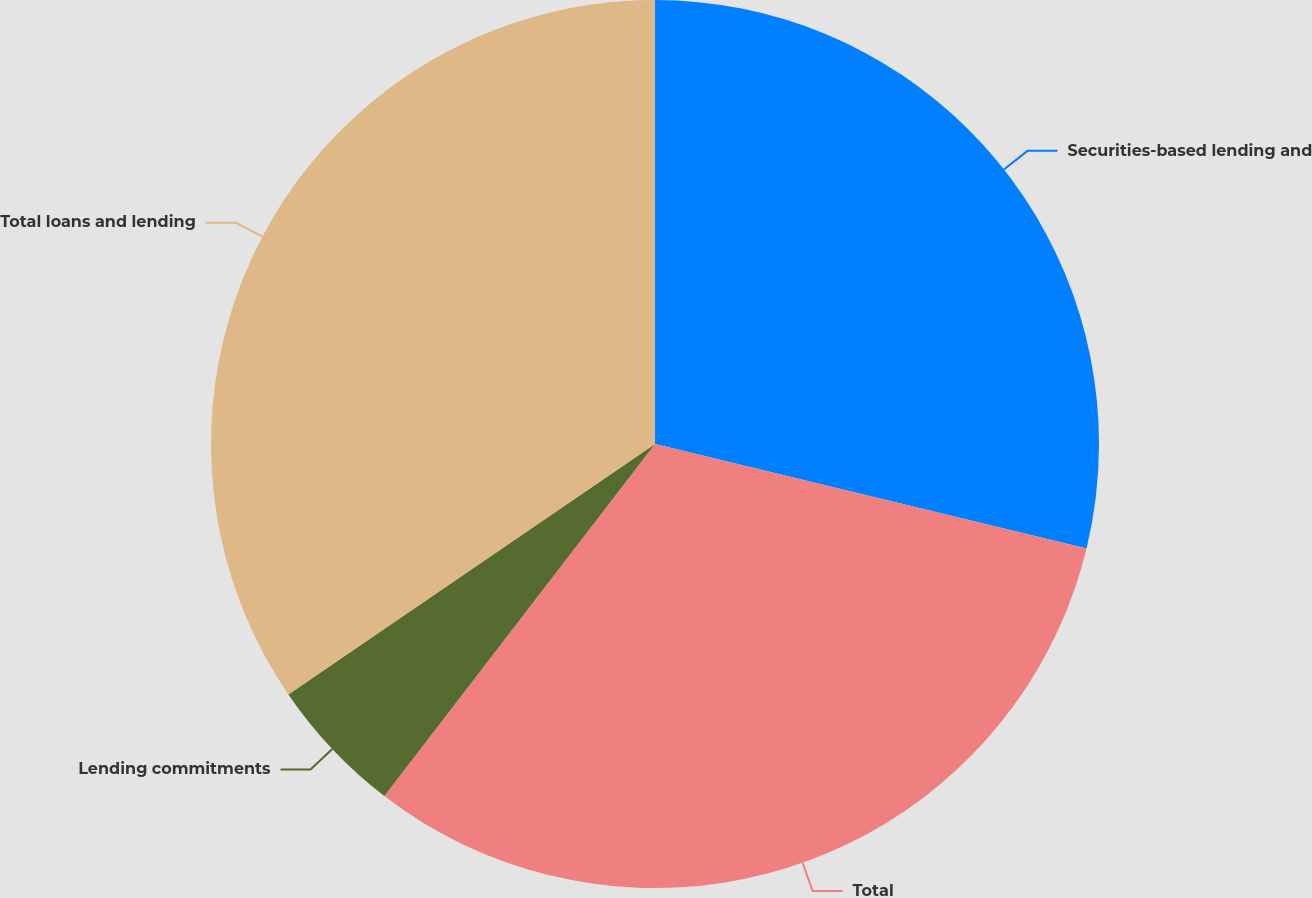Convert chart. <chart><loc_0><loc_0><loc_500><loc_500><pie_chart><fcel>Securities-based lending and<fcel>Total<fcel>Lending commitments<fcel>Total loans and lending<nl><fcel>28.78%<fcel>31.66%<fcel>5.03%<fcel>34.54%<nl></chart> 